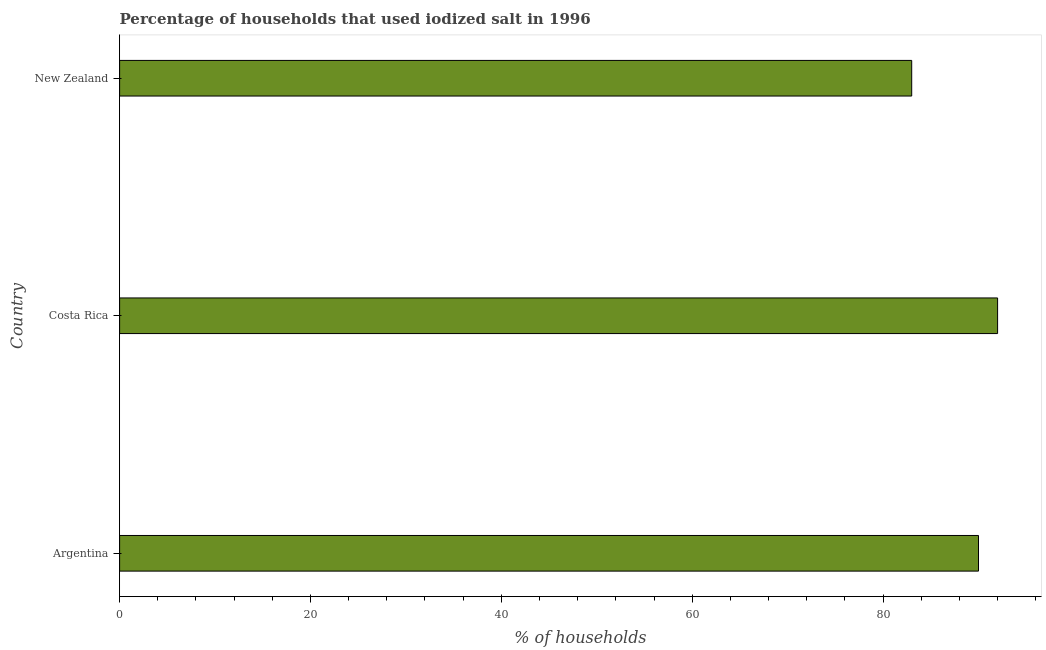Does the graph contain any zero values?
Keep it short and to the point. No. Does the graph contain grids?
Give a very brief answer. No. What is the title of the graph?
Ensure brevity in your answer.  Percentage of households that used iodized salt in 1996. What is the label or title of the X-axis?
Ensure brevity in your answer.  % of households. What is the label or title of the Y-axis?
Your answer should be very brief. Country. What is the percentage of households where iodized salt is consumed in Argentina?
Give a very brief answer. 90. Across all countries, what is the maximum percentage of households where iodized salt is consumed?
Provide a succinct answer. 92. In which country was the percentage of households where iodized salt is consumed maximum?
Offer a terse response. Costa Rica. In which country was the percentage of households where iodized salt is consumed minimum?
Provide a short and direct response. New Zealand. What is the sum of the percentage of households where iodized salt is consumed?
Ensure brevity in your answer.  265. What is the difference between the percentage of households where iodized salt is consumed in Costa Rica and New Zealand?
Ensure brevity in your answer.  9. What is the ratio of the percentage of households where iodized salt is consumed in Costa Rica to that in New Zealand?
Offer a very short reply. 1.11. Is the sum of the percentage of households where iodized salt is consumed in Argentina and New Zealand greater than the maximum percentage of households where iodized salt is consumed across all countries?
Ensure brevity in your answer.  Yes. Are all the bars in the graph horizontal?
Ensure brevity in your answer.  Yes. How many countries are there in the graph?
Ensure brevity in your answer.  3. What is the % of households in Argentina?
Provide a succinct answer. 90. What is the % of households in Costa Rica?
Your answer should be very brief. 92. What is the % of households in New Zealand?
Keep it short and to the point. 83. What is the difference between the % of households in Argentina and Costa Rica?
Your response must be concise. -2. What is the difference between the % of households in Argentina and New Zealand?
Provide a short and direct response. 7. What is the ratio of the % of households in Argentina to that in New Zealand?
Your response must be concise. 1.08. What is the ratio of the % of households in Costa Rica to that in New Zealand?
Offer a terse response. 1.11. 